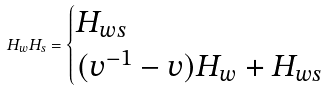<formula> <loc_0><loc_0><loc_500><loc_500>H _ { w } H _ { s } = \begin{cases} H _ { w s } & \\ ( v ^ { - 1 } - v ) H _ { w } + H _ { w s } & \end{cases}</formula> 